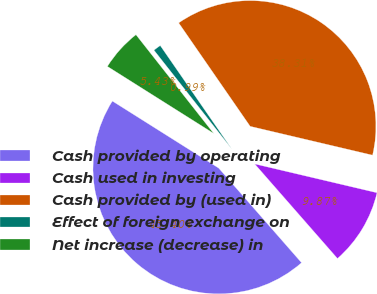Convert chart. <chart><loc_0><loc_0><loc_500><loc_500><pie_chart><fcel>Cash provided by operating<fcel>Cash used in investing<fcel>Cash provided by (used in)<fcel>Effect of foreign exchange on<fcel>Net increase (decrease) in<nl><fcel>45.4%<fcel>9.87%<fcel>38.31%<fcel>0.99%<fcel>5.43%<nl></chart> 